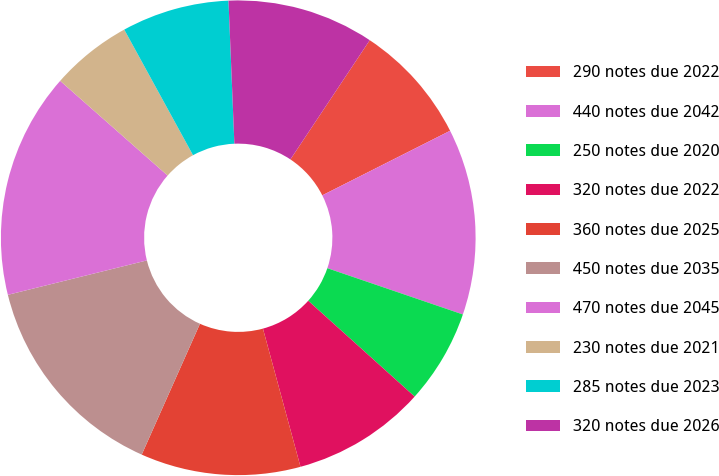Convert chart. <chart><loc_0><loc_0><loc_500><loc_500><pie_chart><fcel>290 notes due 2022<fcel>440 notes due 2042<fcel>250 notes due 2020<fcel>320 notes due 2022<fcel>360 notes due 2025<fcel>450 notes due 2035<fcel>470 notes due 2045<fcel>230 notes due 2021<fcel>285 notes due 2023<fcel>320 notes due 2026<nl><fcel>8.21%<fcel>12.68%<fcel>6.43%<fcel>9.11%<fcel>10.89%<fcel>14.47%<fcel>15.36%<fcel>5.53%<fcel>7.32%<fcel>10.0%<nl></chart> 